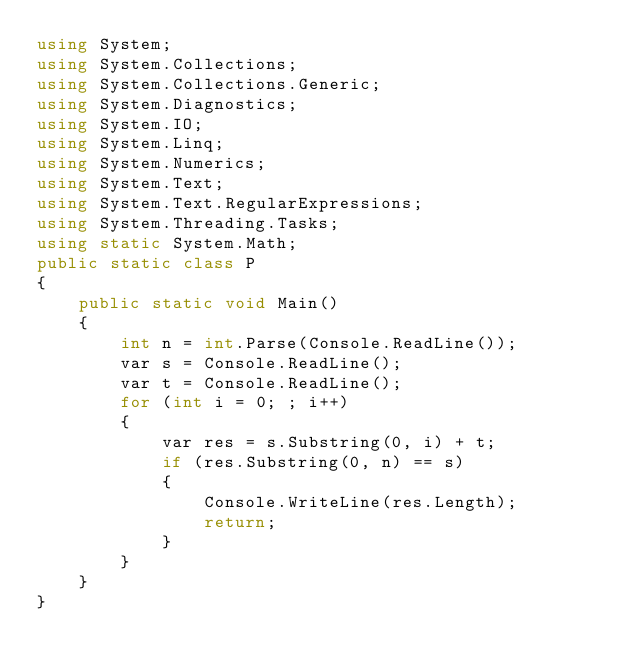<code> <loc_0><loc_0><loc_500><loc_500><_C#_>using System;
using System.Collections;
using System.Collections.Generic;
using System.Diagnostics;
using System.IO;
using System.Linq;
using System.Numerics;
using System.Text;
using System.Text.RegularExpressions;
using System.Threading.Tasks;
using static System.Math;
public static class P
{
    public static void Main()
    {
        int n = int.Parse(Console.ReadLine());
        var s = Console.ReadLine();
        var t = Console.ReadLine();
        for (int i = 0; ; i++)
        {
            var res = s.Substring(0, i) + t;
            if (res.Substring(0, n) == s)
            {
                Console.WriteLine(res.Length);
                return;
            }
        }
    }
}
</code> 